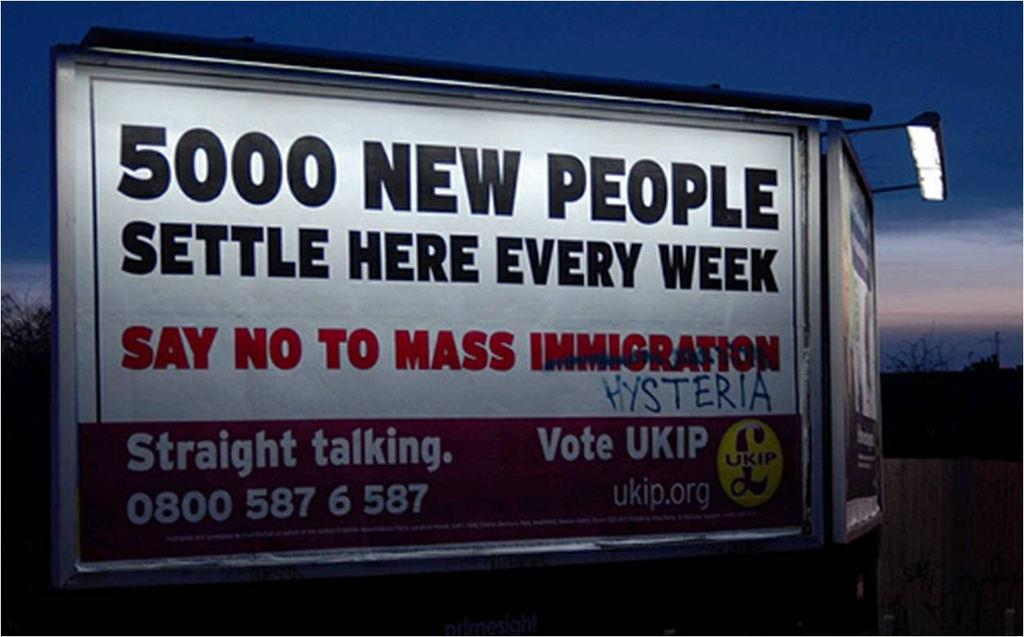<image>
Relay a brief, clear account of the picture shown. A billboard says 5000 new people settle here every week, say no to mass immigration 